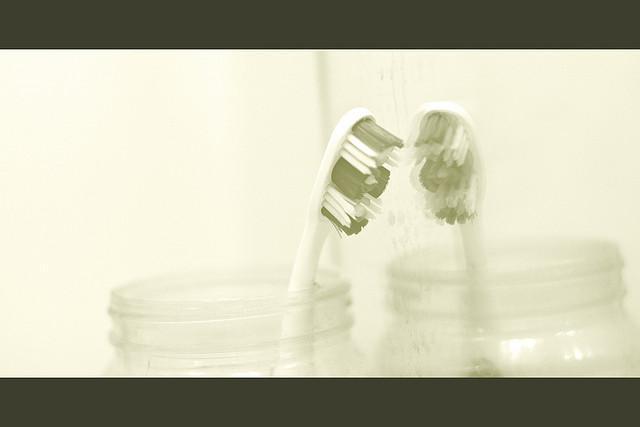How many toothbrushes are visible?
Give a very brief answer. 2. 